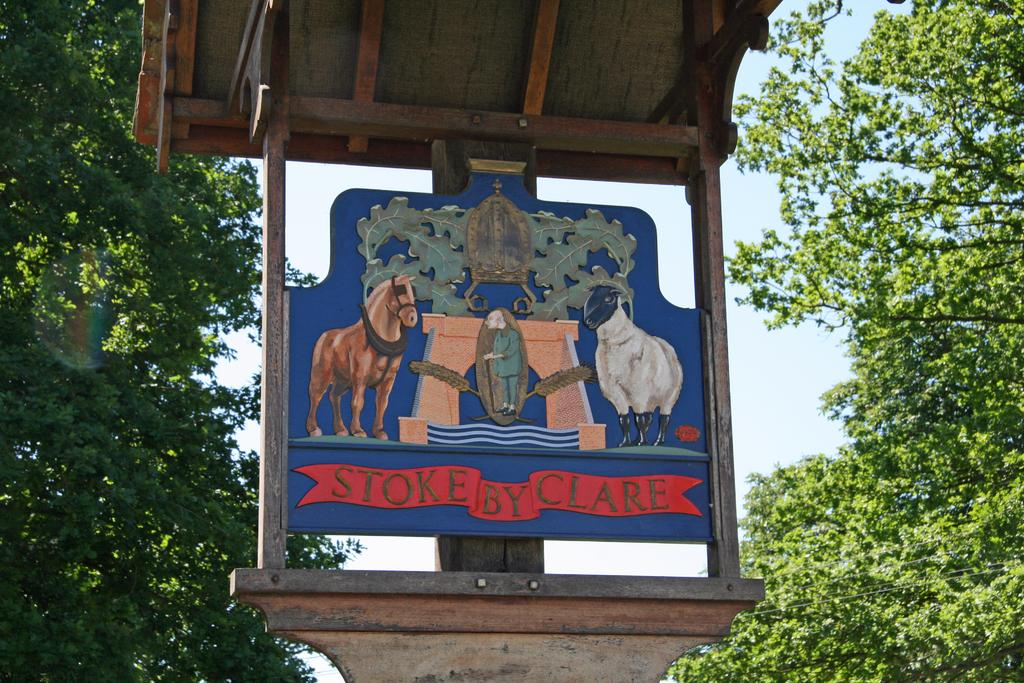What is the main object in the image? There is a wooden board in the image. What can be seen on the left side of the image? There are trees on the left side of the image. What can be seen on the right side of the image? There are trees on the right side of the image. What is visible in the background of the image? The sky is visible in the background of the image. Can you tell me how many beetles are crawling on the wooden board in the image? There are no beetles present on the wooden board in the image. Is there a swing attached to the wooden board in the image? There is no swing attached to the wooden board in the image. 